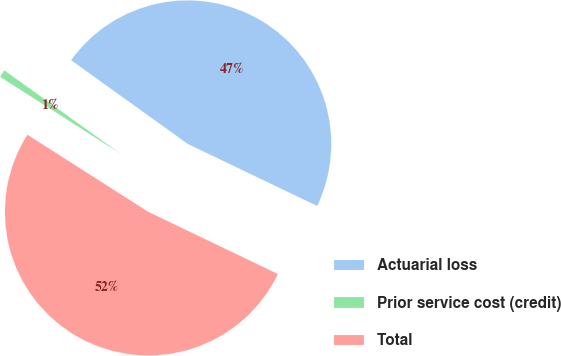Convert chart to OTSL. <chart><loc_0><loc_0><loc_500><loc_500><pie_chart><fcel>Actuarial loss<fcel>Prior service cost (credit)<fcel>Total<nl><fcel>47.2%<fcel>0.87%<fcel>51.92%<nl></chart> 